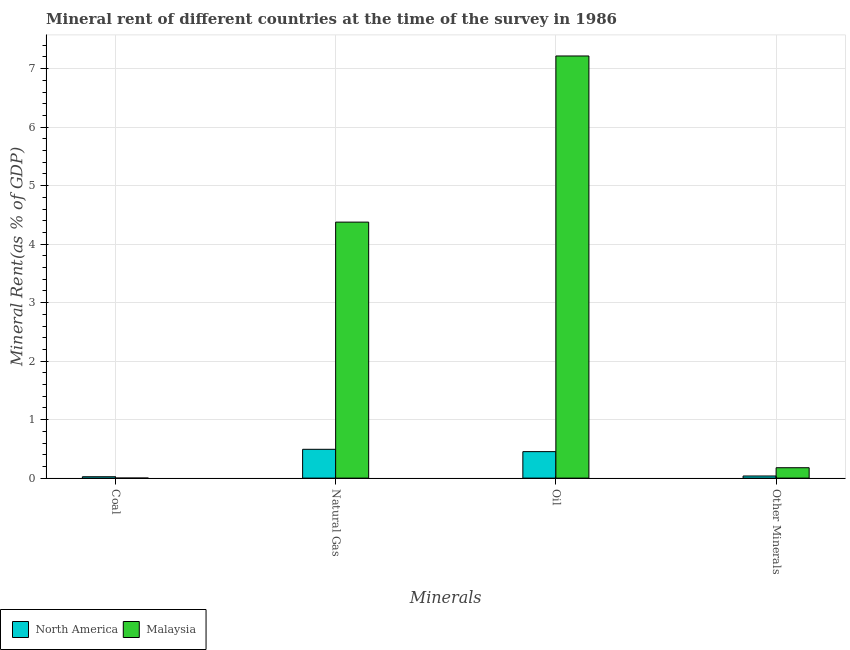How many different coloured bars are there?
Give a very brief answer. 2. How many groups of bars are there?
Give a very brief answer. 4. Are the number of bars per tick equal to the number of legend labels?
Provide a succinct answer. Yes. How many bars are there on the 3rd tick from the left?
Keep it short and to the point. 2. How many bars are there on the 2nd tick from the right?
Ensure brevity in your answer.  2. What is the label of the 1st group of bars from the left?
Give a very brief answer. Coal. What is the  rent of other minerals in Malaysia?
Provide a short and direct response. 0.18. Across all countries, what is the maximum oil rent?
Offer a terse response. 7.22. Across all countries, what is the minimum  rent of other minerals?
Your response must be concise. 0.04. In which country was the  rent of other minerals maximum?
Your answer should be compact. Malaysia. In which country was the oil rent minimum?
Ensure brevity in your answer.  North America. What is the total natural gas rent in the graph?
Your response must be concise. 4.87. What is the difference between the  rent of other minerals in North America and that in Malaysia?
Provide a succinct answer. -0.14. What is the difference between the oil rent in North America and the natural gas rent in Malaysia?
Make the answer very short. -3.92. What is the average oil rent per country?
Provide a succinct answer. 3.83. What is the difference between the oil rent and  rent of other minerals in Malaysia?
Your answer should be compact. 7.04. In how many countries, is the natural gas rent greater than 4.2 %?
Provide a succinct answer. 1. What is the ratio of the natural gas rent in Malaysia to that in North America?
Give a very brief answer. 8.89. Is the natural gas rent in North America less than that in Malaysia?
Give a very brief answer. Yes. What is the difference between the highest and the second highest coal rent?
Ensure brevity in your answer.  0.02. What is the difference between the highest and the lowest oil rent?
Your response must be concise. 6.76. In how many countries, is the natural gas rent greater than the average natural gas rent taken over all countries?
Keep it short and to the point. 1. Is the sum of the coal rent in North America and Malaysia greater than the maximum natural gas rent across all countries?
Your answer should be compact. No. What does the 2nd bar from the left in Natural Gas represents?
Your answer should be compact. Malaysia. What does the 1st bar from the right in Natural Gas represents?
Your answer should be very brief. Malaysia. Is it the case that in every country, the sum of the coal rent and natural gas rent is greater than the oil rent?
Offer a terse response. No. How many bars are there?
Your answer should be compact. 8. Are all the bars in the graph horizontal?
Your response must be concise. No. Are the values on the major ticks of Y-axis written in scientific E-notation?
Keep it short and to the point. No. Does the graph contain any zero values?
Ensure brevity in your answer.  No. Does the graph contain grids?
Offer a very short reply. Yes. Where does the legend appear in the graph?
Keep it short and to the point. Bottom left. How many legend labels are there?
Your answer should be very brief. 2. What is the title of the graph?
Keep it short and to the point. Mineral rent of different countries at the time of the survey in 1986. What is the label or title of the X-axis?
Keep it short and to the point. Minerals. What is the label or title of the Y-axis?
Provide a succinct answer. Mineral Rent(as % of GDP). What is the Mineral Rent(as % of GDP) in North America in Coal?
Ensure brevity in your answer.  0.02. What is the Mineral Rent(as % of GDP) of Malaysia in Coal?
Ensure brevity in your answer.  0. What is the Mineral Rent(as % of GDP) of North America in Natural Gas?
Provide a short and direct response. 0.49. What is the Mineral Rent(as % of GDP) in Malaysia in Natural Gas?
Provide a short and direct response. 4.38. What is the Mineral Rent(as % of GDP) of North America in Oil?
Make the answer very short. 0.45. What is the Mineral Rent(as % of GDP) of Malaysia in Oil?
Give a very brief answer. 7.22. What is the Mineral Rent(as % of GDP) in North America in Other Minerals?
Your answer should be compact. 0.04. What is the Mineral Rent(as % of GDP) in Malaysia in Other Minerals?
Give a very brief answer. 0.18. Across all Minerals, what is the maximum Mineral Rent(as % of GDP) in North America?
Give a very brief answer. 0.49. Across all Minerals, what is the maximum Mineral Rent(as % of GDP) of Malaysia?
Your answer should be very brief. 7.22. Across all Minerals, what is the minimum Mineral Rent(as % of GDP) in North America?
Provide a short and direct response. 0.02. Across all Minerals, what is the minimum Mineral Rent(as % of GDP) in Malaysia?
Offer a very short reply. 0. What is the total Mineral Rent(as % of GDP) of Malaysia in the graph?
Provide a succinct answer. 11.77. What is the difference between the Mineral Rent(as % of GDP) of North America in Coal and that in Natural Gas?
Keep it short and to the point. -0.47. What is the difference between the Mineral Rent(as % of GDP) of Malaysia in Coal and that in Natural Gas?
Offer a very short reply. -4.38. What is the difference between the Mineral Rent(as % of GDP) of North America in Coal and that in Oil?
Your response must be concise. -0.43. What is the difference between the Mineral Rent(as % of GDP) of Malaysia in Coal and that in Oil?
Offer a terse response. -7.22. What is the difference between the Mineral Rent(as % of GDP) in North America in Coal and that in Other Minerals?
Your response must be concise. -0.01. What is the difference between the Mineral Rent(as % of GDP) in Malaysia in Coal and that in Other Minerals?
Give a very brief answer. -0.18. What is the difference between the Mineral Rent(as % of GDP) of North America in Natural Gas and that in Oil?
Provide a succinct answer. 0.04. What is the difference between the Mineral Rent(as % of GDP) of Malaysia in Natural Gas and that in Oil?
Provide a short and direct response. -2.84. What is the difference between the Mineral Rent(as % of GDP) in North America in Natural Gas and that in Other Minerals?
Make the answer very short. 0.46. What is the difference between the Mineral Rent(as % of GDP) of Malaysia in Natural Gas and that in Other Minerals?
Keep it short and to the point. 4.2. What is the difference between the Mineral Rent(as % of GDP) in North America in Oil and that in Other Minerals?
Offer a terse response. 0.42. What is the difference between the Mineral Rent(as % of GDP) in Malaysia in Oil and that in Other Minerals?
Your answer should be very brief. 7.04. What is the difference between the Mineral Rent(as % of GDP) of North America in Coal and the Mineral Rent(as % of GDP) of Malaysia in Natural Gas?
Your answer should be compact. -4.35. What is the difference between the Mineral Rent(as % of GDP) in North America in Coal and the Mineral Rent(as % of GDP) in Malaysia in Oil?
Keep it short and to the point. -7.19. What is the difference between the Mineral Rent(as % of GDP) in North America in Coal and the Mineral Rent(as % of GDP) in Malaysia in Other Minerals?
Offer a terse response. -0.15. What is the difference between the Mineral Rent(as % of GDP) of North America in Natural Gas and the Mineral Rent(as % of GDP) of Malaysia in Oil?
Give a very brief answer. -6.72. What is the difference between the Mineral Rent(as % of GDP) of North America in Natural Gas and the Mineral Rent(as % of GDP) of Malaysia in Other Minerals?
Give a very brief answer. 0.31. What is the difference between the Mineral Rent(as % of GDP) of North America in Oil and the Mineral Rent(as % of GDP) of Malaysia in Other Minerals?
Give a very brief answer. 0.28. What is the average Mineral Rent(as % of GDP) of North America per Minerals?
Give a very brief answer. 0.25. What is the average Mineral Rent(as % of GDP) in Malaysia per Minerals?
Provide a short and direct response. 2.94. What is the difference between the Mineral Rent(as % of GDP) of North America and Mineral Rent(as % of GDP) of Malaysia in Coal?
Your response must be concise. 0.02. What is the difference between the Mineral Rent(as % of GDP) of North America and Mineral Rent(as % of GDP) of Malaysia in Natural Gas?
Make the answer very short. -3.88. What is the difference between the Mineral Rent(as % of GDP) in North America and Mineral Rent(as % of GDP) in Malaysia in Oil?
Ensure brevity in your answer.  -6.76. What is the difference between the Mineral Rent(as % of GDP) of North America and Mineral Rent(as % of GDP) of Malaysia in Other Minerals?
Your answer should be compact. -0.14. What is the ratio of the Mineral Rent(as % of GDP) of North America in Coal to that in Natural Gas?
Your answer should be compact. 0.05. What is the ratio of the Mineral Rent(as % of GDP) in North America in Coal to that in Oil?
Provide a succinct answer. 0.05. What is the ratio of the Mineral Rent(as % of GDP) in North America in Coal to that in Other Minerals?
Your response must be concise. 0.64. What is the ratio of the Mineral Rent(as % of GDP) in Malaysia in Coal to that in Other Minerals?
Provide a succinct answer. 0. What is the ratio of the Mineral Rent(as % of GDP) of North America in Natural Gas to that in Oil?
Make the answer very short. 1.09. What is the ratio of the Mineral Rent(as % of GDP) in Malaysia in Natural Gas to that in Oil?
Offer a very short reply. 0.61. What is the ratio of the Mineral Rent(as % of GDP) in North America in Natural Gas to that in Other Minerals?
Make the answer very short. 13.51. What is the ratio of the Mineral Rent(as % of GDP) of Malaysia in Natural Gas to that in Other Minerals?
Ensure brevity in your answer.  24.64. What is the ratio of the Mineral Rent(as % of GDP) in North America in Oil to that in Other Minerals?
Provide a succinct answer. 12.42. What is the ratio of the Mineral Rent(as % of GDP) of Malaysia in Oil to that in Other Minerals?
Your answer should be compact. 40.63. What is the difference between the highest and the second highest Mineral Rent(as % of GDP) in North America?
Provide a succinct answer. 0.04. What is the difference between the highest and the second highest Mineral Rent(as % of GDP) of Malaysia?
Keep it short and to the point. 2.84. What is the difference between the highest and the lowest Mineral Rent(as % of GDP) in North America?
Give a very brief answer. 0.47. What is the difference between the highest and the lowest Mineral Rent(as % of GDP) in Malaysia?
Offer a very short reply. 7.22. 